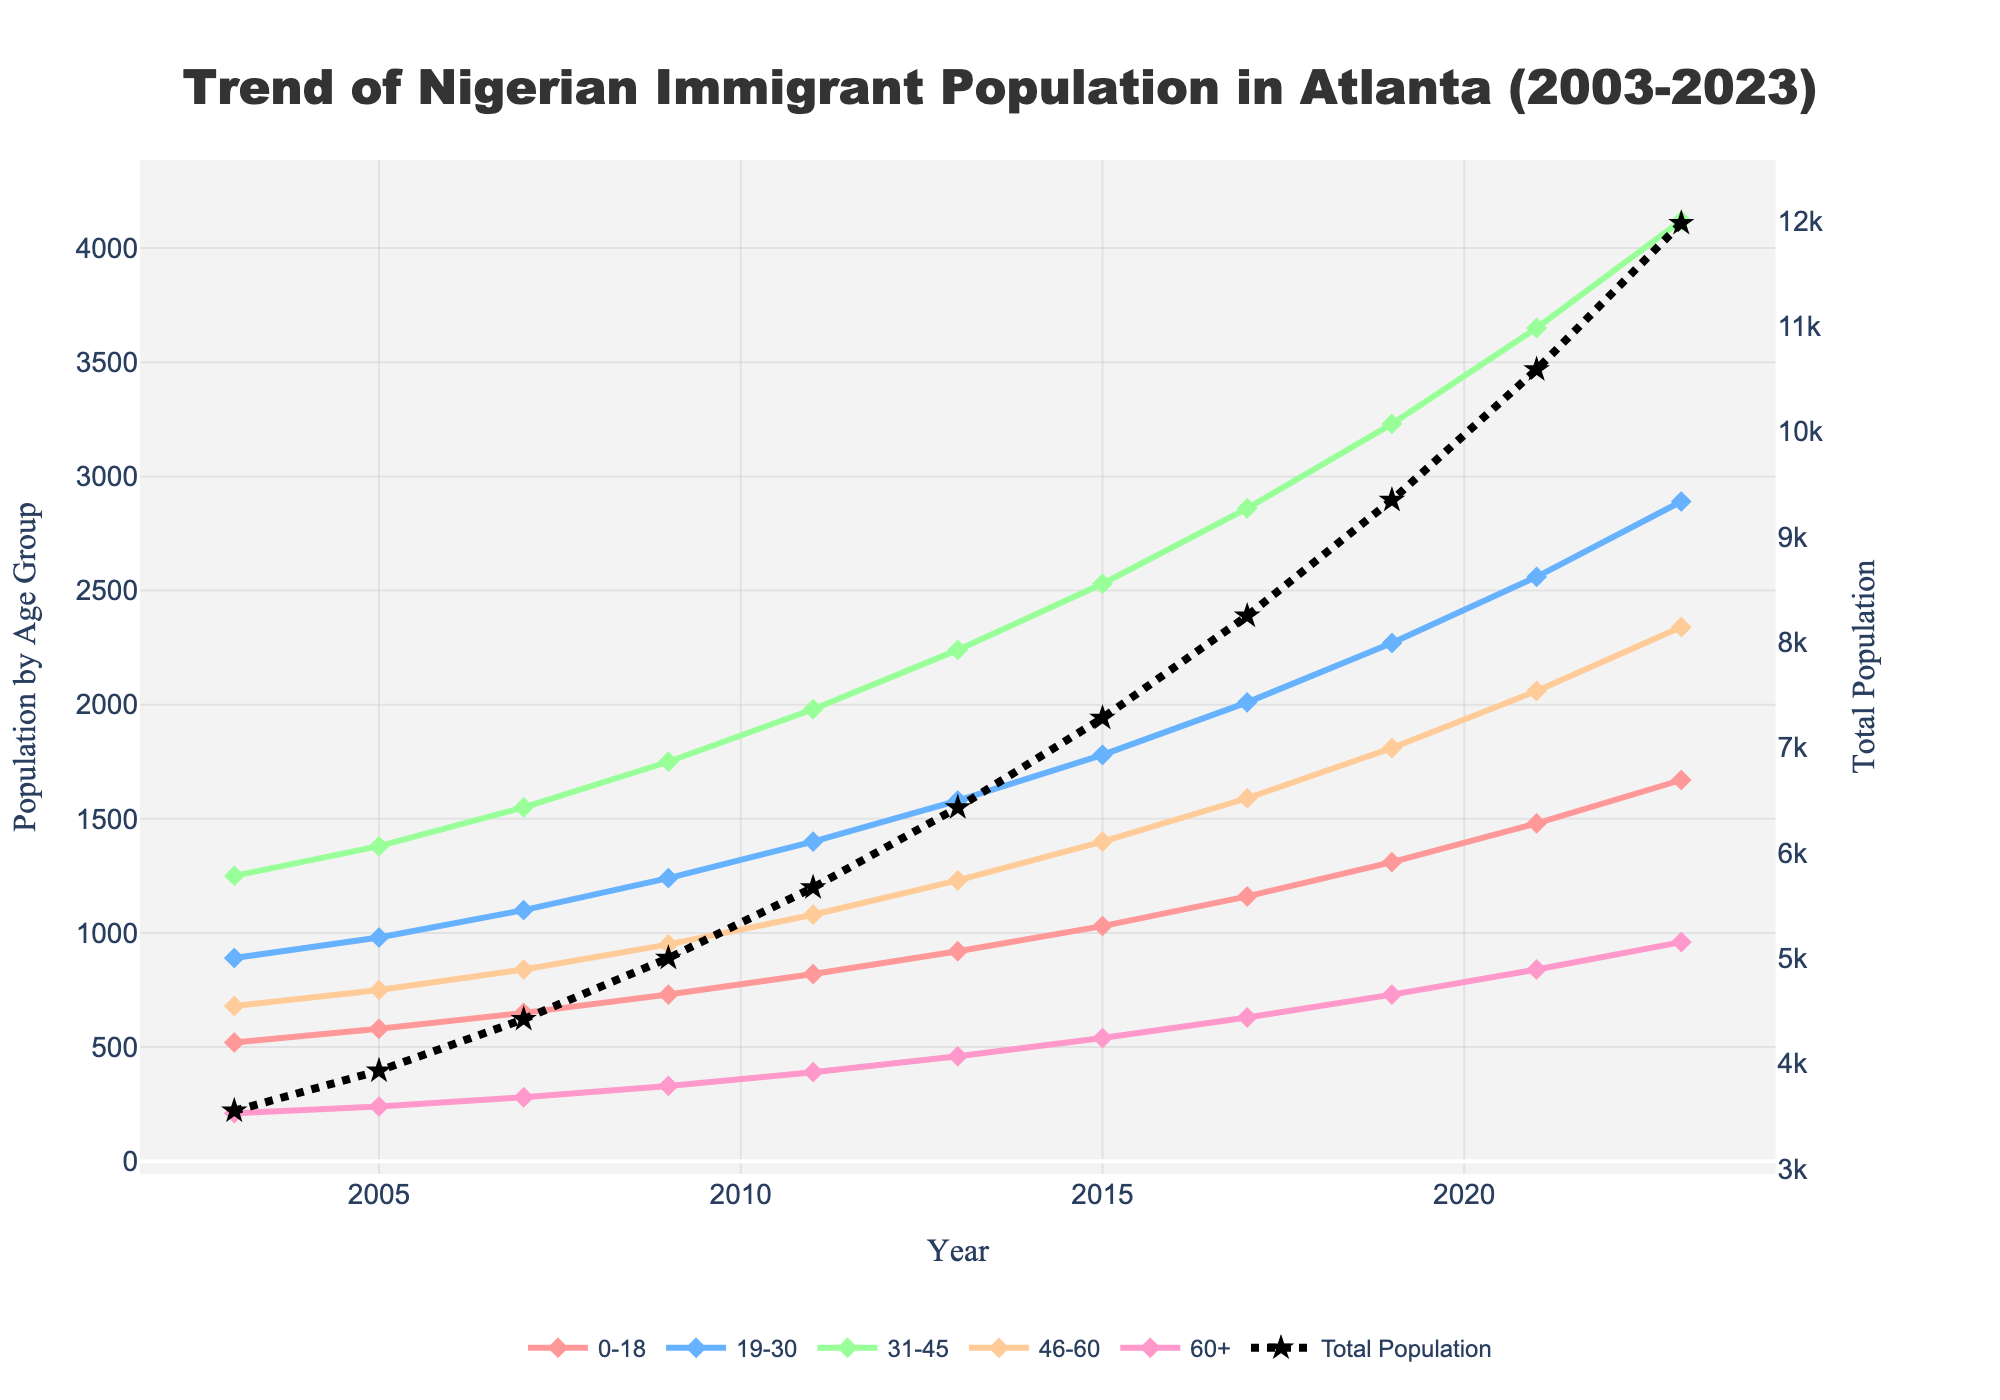What's the total population in 2023? The total population in 2023 can be found by summing the values of all the age groups for that year: 1670 (0-18) + 2890 (19-30) + 4120 (31-45) + 2340 (46-60) + 960 (60+).
Answer: 11980 Which age group had the highest population in 2023? By comparing the population counts for each age group in 2023, the age group 31-45 has the highest population with 4120 people.
Answer: 31-45 How did the population of the 19-30 age group change from 2003 to 2023? The population of the 19-30 age group in 2003 was 890 and in 2023 it is 2890. The change is calculated by subtracting the 2003 value from the 2023 value: 2890 - 890.
Answer: 2000 Which year saw the biggest increase in the total population compared to the previous period? By reviewing the total population for each successive period, the biggest increase occurred from 2021 (10590) to 2023 (11980), with an increase of 1390.
Answer: 2023 What is the trend for the 0-18 age group's population from 2003 to 2023? The trend for the 0-18 age group's population shows a consistent increase over the years from 520 in 2003 to 1670 in 2023.
Answer: Increasing Which age group has the least population in 2023? By comparing the population counts for each age group in 2023, the age group 60+ has the least population with 960 people.
Answer: 60+ How much has the population of the 46-60 age group grown from 2009 to 2023? The population of the 46-60 age group in 2009 was 950 and in 2023 it is 2340. The growth is calculated by subtracting the 2009 value from the 2023 value: 2340 - 950.
Answer: 1390 What is the average population for the age group 31-45 from 2003 to 2023? Sum the population of each recorded year for the age group 31-45: (1250 + 1380 + 1550 + 1750 + 1980 + 2240 + 2530 + 2860 + 3230 + 3650 + 4120), then divide by the number of years (11). (1250+1380+1550+1750+1980+2240+2530+2860+3230+3650+4120) / 11 = 2440.
Answer: 2440 Which year had the highest total population before 2023, and what was that population? Before 2023, the highest total population was in 2021, with the total being the sum of all age groups for that year: 1480 + 2560 + 3650 + 2060 + 840.
Answer: 10590 